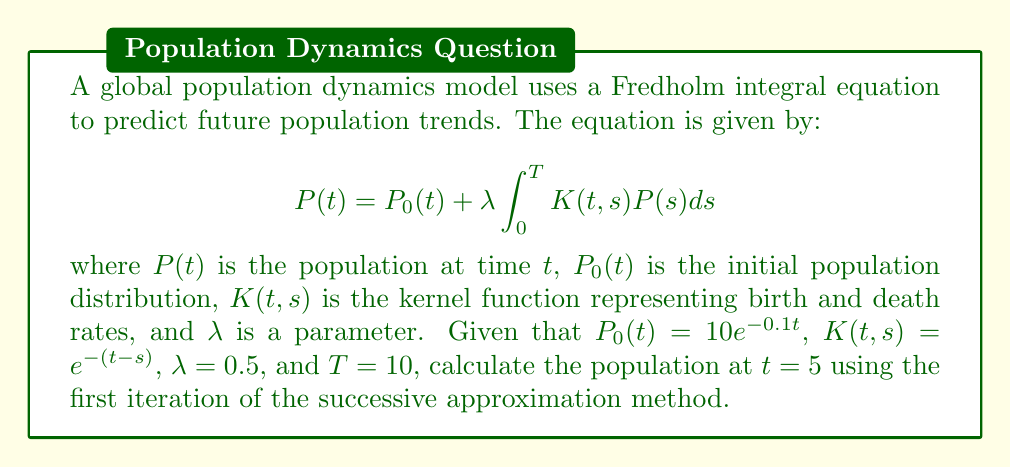Provide a solution to this math problem. To solve this problem using the successive approximation method, we'll follow these steps:

1) The first iteration of the successive approximation method uses $P_0(t)$ as the initial guess for $P(t)$ in the integral. So, we start with:

   $$P_1(t) = P_0(t) + \lambda \int_0^T K(t,s)P_0(s)ds$$

2) Substitute the given values:
   $$P_1(5) = 10e^{-0.1(5)} + 0.5 \int_0^{10} e^{-(5-s)}(10e^{-0.1s})ds$$

3) Simplify the first term:
   $$P_1(5) = 10e^{-0.5} + 5 \int_0^{10} e^{-5+s}e^{-0.1s}ds$$

4) Combine exponents in the integral:
   $$P_1(5) = 10e^{-0.5} + 5e^{-5} \int_0^{10} e^{0.9s}ds$$

5) Evaluate the integral:
   $$P_1(5) = 10e^{-0.5} + 5e^{-5} \left[\frac{1}{0.9}e^{0.9s}\right]_0^{10}$$
   $$= 10e^{-0.5} + 5e^{-5} \cdot \frac{1}{0.9}(e^9 - 1)$$

6) Calculate the final result:
   $$P_1(5) \approx 6.0653 + 548.6240 = 554.6893$$
Answer: $554.6893$ 